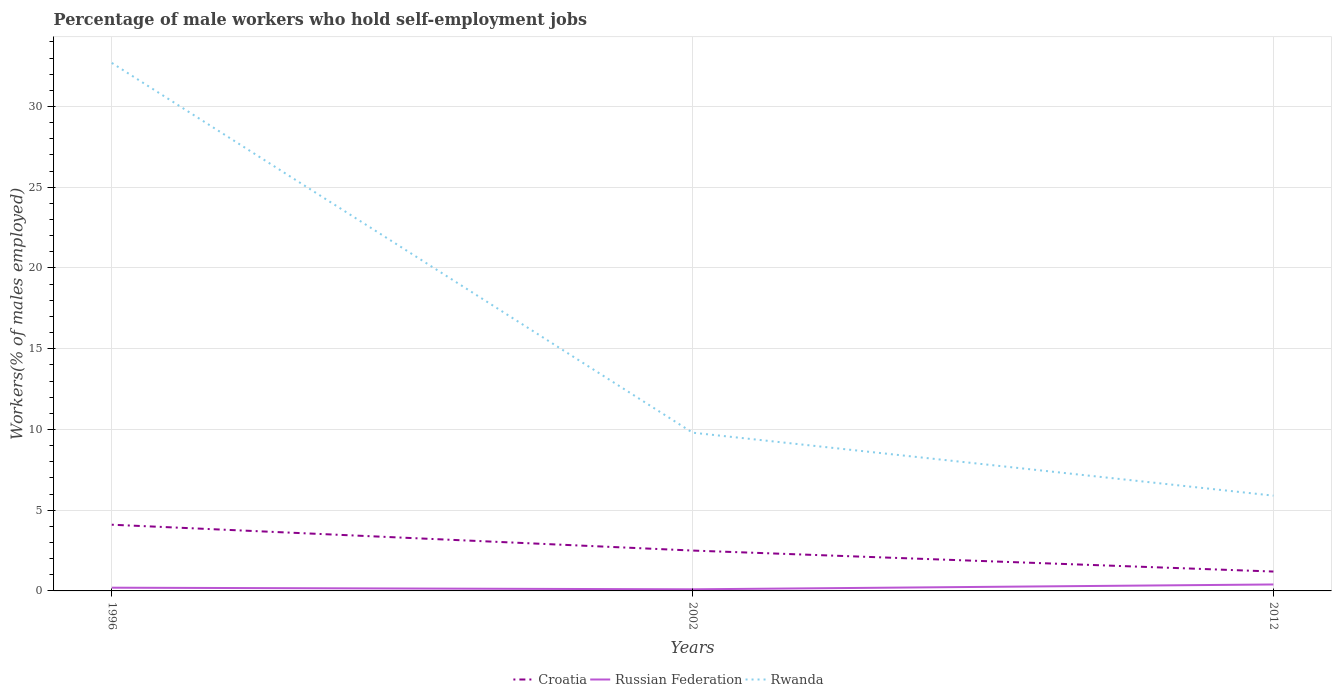Is the number of lines equal to the number of legend labels?
Give a very brief answer. Yes. Across all years, what is the maximum percentage of self-employed male workers in Rwanda?
Give a very brief answer. 5.9. In which year was the percentage of self-employed male workers in Rwanda maximum?
Your answer should be very brief. 2012. What is the total percentage of self-employed male workers in Russian Federation in the graph?
Offer a very short reply. -0.2. What is the difference between the highest and the second highest percentage of self-employed male workers in Rwanda?
Give a very brief answer. 26.8. What is the difference between the highest and the lowest percentage of self-employed male workers in Russian Federation?
Provide a succinct answer. 1. Is the percentage of self-employed male workers in Russian Federation strictly greater than the percentage of self-employed male workers in Croatia over the years?
Provide a succinct answer. Yes. How many years are there in the graph?
Keep it short and to the point. 3. What is the difference between two consecutive major ticks on the Y-axis?
Provide a short and direct response. 5. Are the values on the major ticks of Y-axis written in scientific E-notation?
Offer a terse response. No. Where does the legend appear in the graph?
Your answer should be very brief. Bottom center. What is the title of the graph?
Make the answer very short. Percentage of male workers who hold self-employment jobs. Does "Poland" appear as one of the legend labels in the graph?
Your answer should be compact. No. What is the label or title of the Y-axis?
Give a very brief answer. Workers(% of males employed). What is the Workers(% of males employed) in Croatia in 1996?
Provide a succinct answer. 4.1. What is the Workers(% of males employed) of Russian Federation in 1996?
Your answer should be very brief. 0.2. What is the Workers(% of males employed) of Rwanda in 1996?
Make the answer very short. 32.7. What is the Workers(% of males employed) in Croatia in 2002?
Offer a terse response. 2.5. What is the Workers(% of males employed) of Russian Federation in 2002?
Give a very brief answer. 0.1. What is the Workers(% of males employed) of Rwanda in 2002?
Give a very brief answer. 9.8. What is the Workers(% of males employed) in Croatia in 2012?
Offer a very short reply. 1.2. What is the Workers(% of males employed) of Russian Federation in 2012?
Ensure brevity in your answer.  0.4. What is the Workers(% of males employed) of Rwanda in 2012?
Keep it short and to the point. 5.9. Across all years, what is the maximum Workers(% of males employed) in Croatia?
Give a very brief answer. 4.1. Across all years, what is the maximum Workers(% of males employed) of Russian Federation?
Keep it short and to the point. 0.4. Across all years, what is the maximum Workers(% of males employed) of Rwanda?
Offer a terse response. 32.7. Across all years, what is the minimum Workers(% of males employed) in Croatia?
Your response must be concise. 1.2. Across all years, what is the minimum Workers(% of males employed) in Russian Federation?
Your answer should be compact. 0.1. Across all years, what is the minimum Workers(% of males employed) of Rwanda?
Make the answer very short. 5.9. What is the total Workers(% of males employed) in Croatia in the graph?
Give a very brief answer. 7.8. What is the total Workers(% of males employed) of Rwanda in the graph?
Your response must be concise. 48.4. What is the difference between the Workers(% of males employed) of Croatia in 1996 and that in 2002?
Ensure brevity in your answer.  1.6. What is the difference between the Workers(% of males employed) in Rwanda in 1996 and that in 2002?
Provide a short and direct response. 22.9. What is the difference between the Workers(% of males employed) in Russian Federation in 1996 and that in 2012?
Make the answer very short. -0.2. What is the difference between the Workers(% of males employed) in Rwanda in 1996 and that in 2012?
Give a very brief answer. 26.8. What is the difference between the Workers(% of males employed) in Russian Federation in 1996 and the Workers(% of males employed) in Rwanda in 2002?
Your response must be concise. -9.6. What is the difference between the Workers(% of males employed) of Russian Federation in 1996 and the Workers(% of males employed) of Rwanda in 2012?
Provide a short and direct response. -5.7. What is the difference between the Workers(% of males employed) in Croatia in 2002 and the Workers(% of males employed) in Rwanda in 2012?
Provide a short and direct response. -3.4. What is the difference between the Workers(% of males employed) of Russian Federation in 2002 and the Workers(% of males employed) of Rwanda in 2012?
Provide a succinct answer. -5.8. What is the average Workers(% of males employed) of Croatia per year?
Your answer should be very brief. 2.6. What is the average Workers(% of males employed) in Russian Federation per year?
Your response must be concise. 0.23. What is the average Workers(% of males employed) of Rwanda per year?
Provide a short and direct response. 16.13. In the year 1996, what is the difference between the Workers(% of males employed) of Croatia and Workers(% of males employed) of Russian Federation?
Offer a very short reply. 3.9. In the year 1996, what is the difference between the Workers(% of males employed) in Croatia and Workers(% of males employed) in Rwanda?
Keep it short and to the point. -28.6. In the year 1996, what is the difference between the Workers(% of males employed) in Russian Federation and Workers(% of males employed) in Rwanda?
Offer a terse response. -32.5. In the year 2002, what is the difference between the Workers(% of males employed) in Croatia and Workers(% of males employed) in Russian Federation?
Provide a short and direct response. 2.4. In the year 2012, what is the difference between the Workers(% of males employed) of Croatia and Workers(% of males employed) of Rwanda?
Ensure brevity in your answer.  -4.7. In the year 2012, what is the difference between the Workers(% of males employed) in Russian Federation and Workers(% of males employed) in Rwanda?
Offer a terse response. -5.5. What is the ratio of the Workers(% of males employed) of Croatia in 1996 to that in 2002?
Give a very brief answer. 1.64. What is the ratio of the Workers(% of males employed) in Rwanda in 1996 to that in 2002?
Offer a terse response. 3.34. What is the ratio of the Workers(% of males employed) of Croatia in 1996 to that in 2012?
Offer a very short reply. 3.42. What is the ratio of the Workers(% of males employed) of Russian Federation in 1996 to that in 2012?
Make the answer very short. 0.5. What is the ratio of the Workers(% of males employed) in Rwanda in 1996 to that in 2012?
Your answer should be very brief. 5.54. What is the ratio of the Workers(% of males employed) in Croatia in 2002 to that in 2012?
Your answer should be very brief. 2.08. What is the ratio of the Workers(% of males employed) in Rwanda in 2002 to that in 2012?
Provide a short and direct response. 1.66. What is the difference between the highest and the second highest Workers(% of males employed) in Rwanda?
Make the answer very short. 22.9. What is the difference between the highest and the lowest Workers(% of males employed) in Croatia?
Your answer should be very brief. 2.9. What is the difference between the highest and the lowest Workers(% of males employed) of Rwanda?
Offer a terse response. 26.8. 